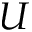<formula> <loc_0><loc_0><loc_500><loc_500>U</formula> 